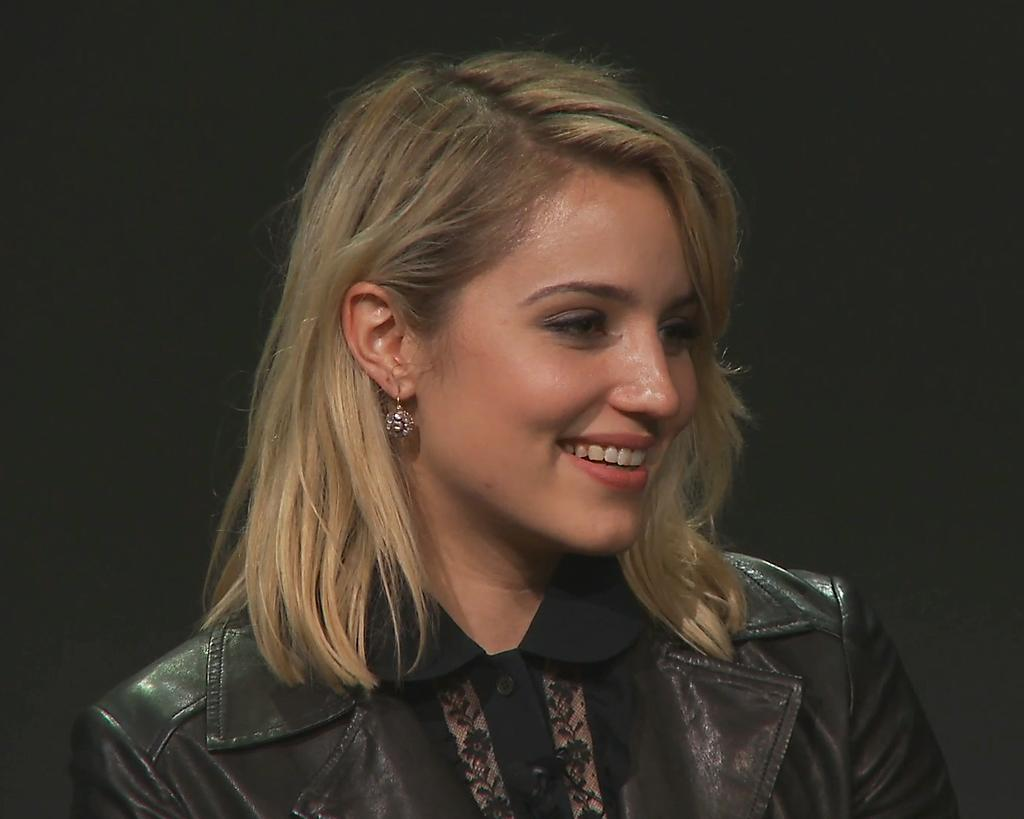Who is the main subject in the image? There is a lady in the image. What is the lady doing in the image? The lady is smiling in the image. In which direction is the lady looking? The lady is looking to the right side of the image. What can be observed about the background of the image? The background of the image is dark. What type of guitar is the lady playing in the image? There is no guitar present in the image; the lady is simply smiling and looking to the right side. 